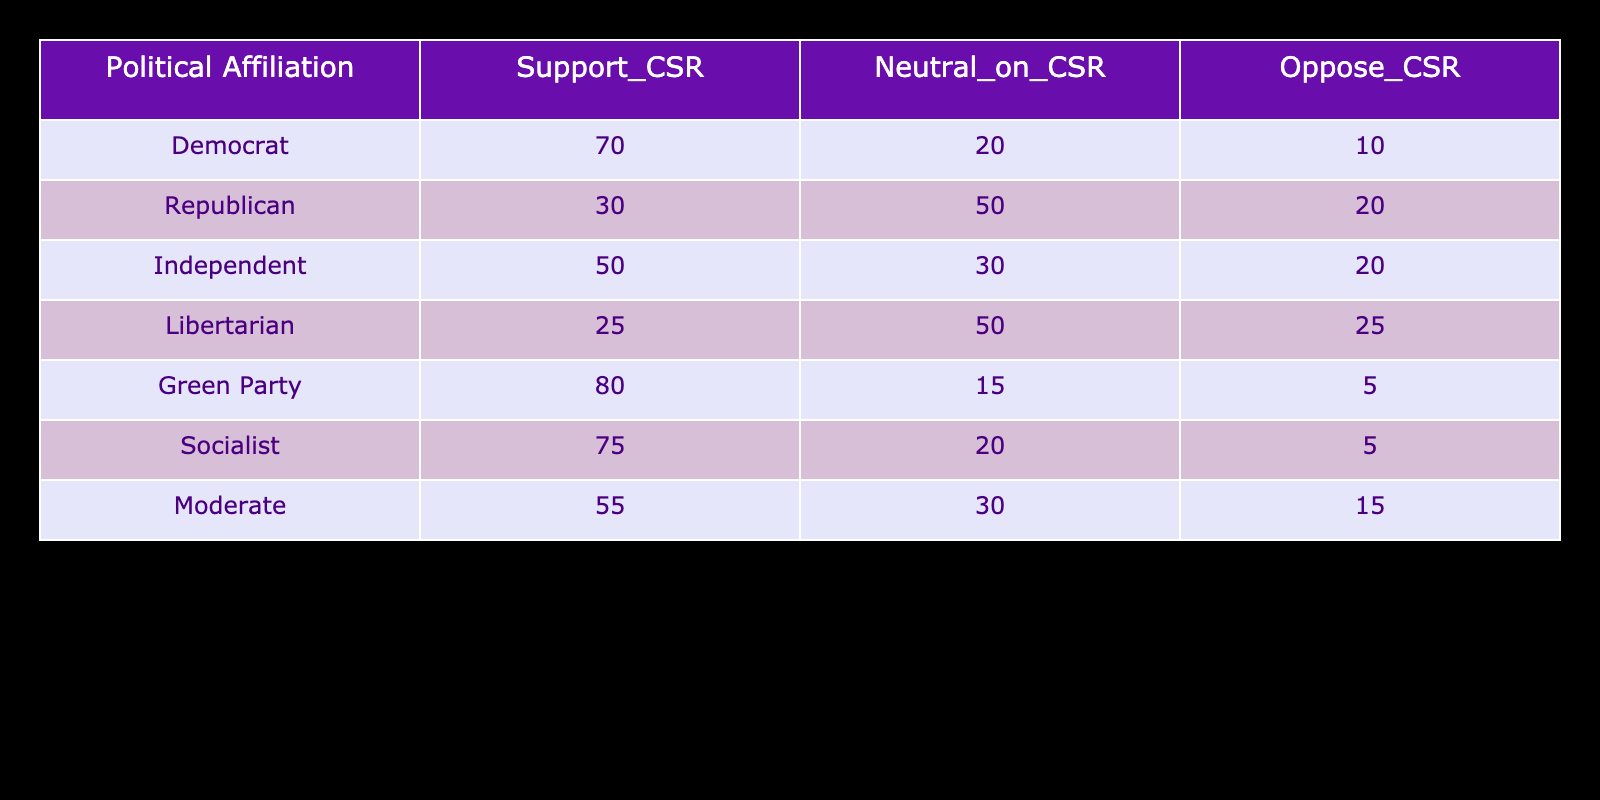What is the total number of individuals who support corporate social responsibility among Independents? In the table, the number of Independents who support CSR is listed as 50. This value can be directly retrieved from the table under the column "Support_CSR" for the row labeled "Independent."
Answer: 50 What percentage of Democrats oppose corporate social responsibility? There are a total of 100 individuals represented in the Democrat row. Of these, 10 oppose CSR. The percentage is calculated as (10/100) * 100 = 10%.
Answer: 10% How many political affiliations have more than 70 percent support for CSR? By examining the "Support_CSR" column, three affiliations (Democrat, Green Party, and Socialist) have support levels above 70 percent (70, 80, and 75). Therefore, the total count of such affiliations is 3.
Answer: 3 Is it true that Libertarians have a higher percentage of Neutral views on CSR compared to Republicans? The Neutral percentages are 50 for Libertarians and 50 for Republicans. Since both percentages are equal, the statement is false.
Answer: No What is the average percentage of support for CSR across all political affiliations? To find the average, we sum the support percentages: (70 + 30 + 50 + 25 + 80 + 75 + 55) = 385. There are 7 political affiliations, so the average is calculated as 385 / 7 ≈ 55. Thus, the average support for CSR is approximately 55%.
Answer: 55% Which political affiliation has the least support for CSR? By examining the "Support_CSR" column, the lowest support is observed among Libertarians with a value of 25. This can be conclusively determined by comparing all values in that column.
Answer: Libertarian Calculate the difference in support for CSR between Democrats and Socialists. Democrats have a support percentage of 70%, while Socialists have 75%. The difference is 75 - 70 = 5, indicating that Socialists have 5% more support for CSR than Democrats.
Answer: 5 What is the only political affiliation that has less than 10 percent support for CSR? Looking at the support percentages, no political affiliation falls below 10 percent. Thus, it can be established that the statement is false.
Answer: No 